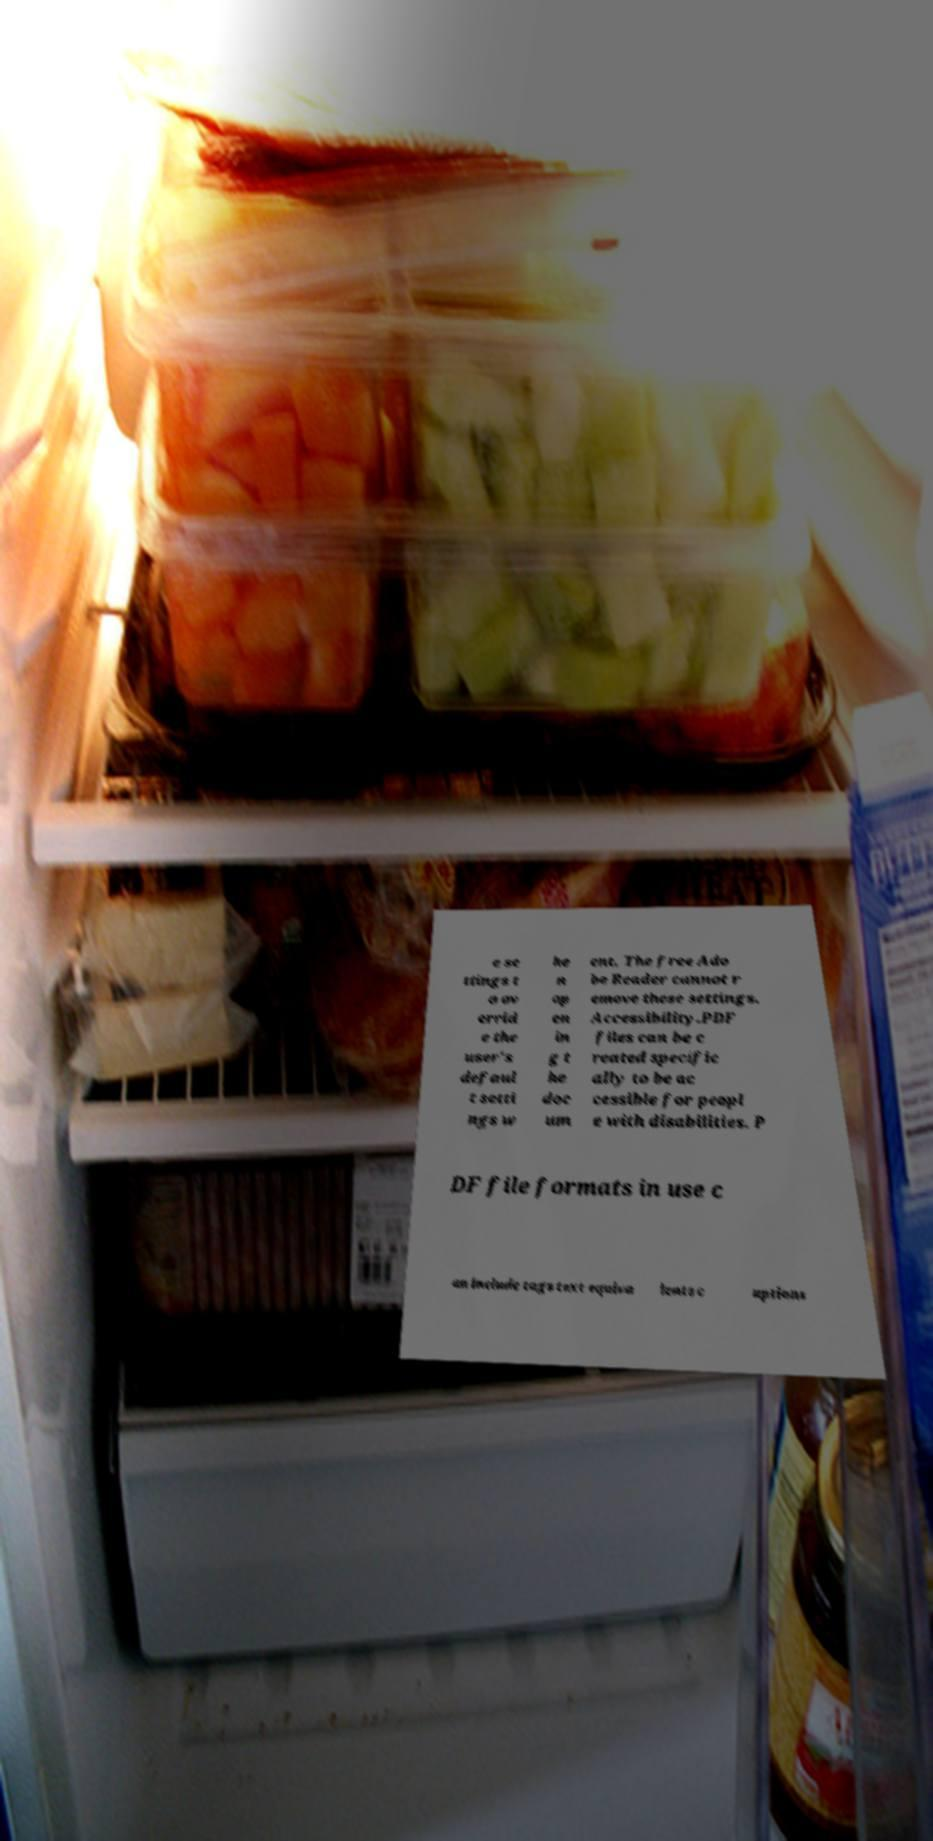Please read and relay the text visible in this image. What does it say? e se ttings t o ov errid e the user's defaul t setti ngs w he n op en in g t he doc um ent. The free Ado be Reader cannot r emove these settings. Accessibility.PDF files can be c reated specific ally to be ac cessible for peopl e with disabilities. P DF file formats in use c an include tags text equiva lents c aptions 